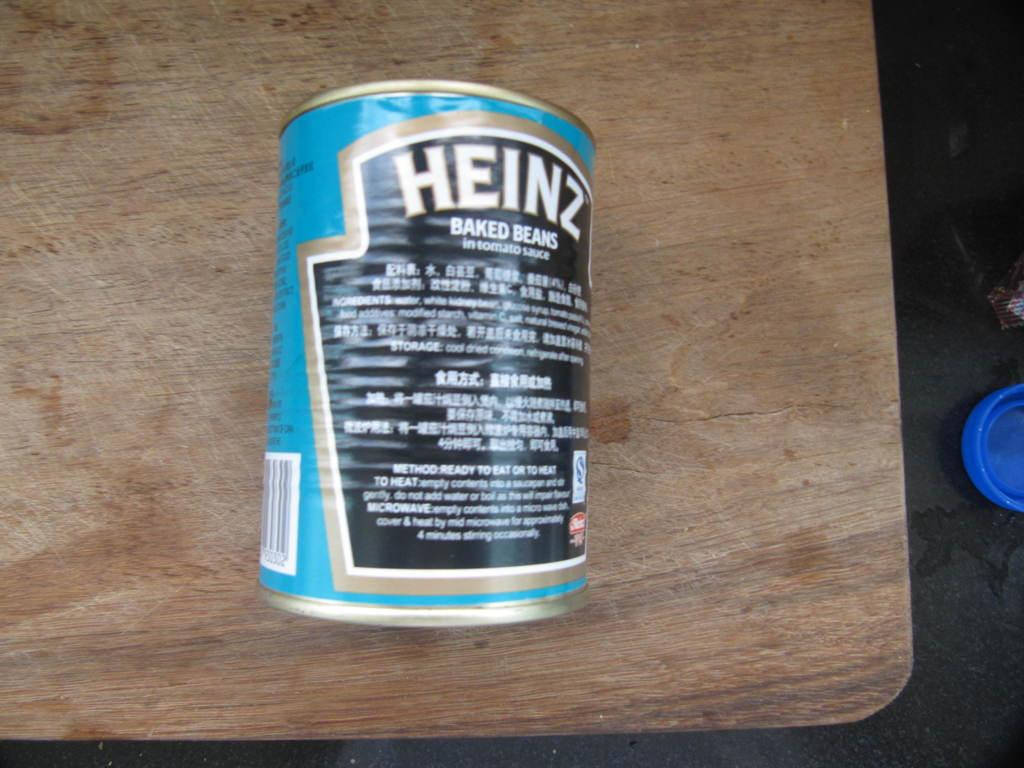<image>
Present a compact description of the photo's key features. The back of a can of Heinz baked beans. 